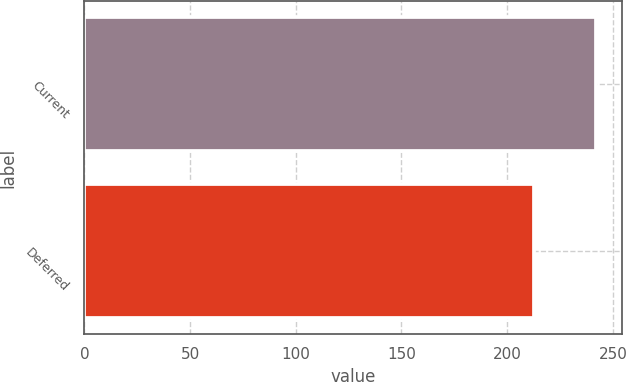Convert chart to OTSL. <chart><loc_0><loc_0><loc_500><loc_500><bar_chart><fcel>Current<fcel>Deferred<nl><fcel>242.2<fcel>212.5<nl></chart> 